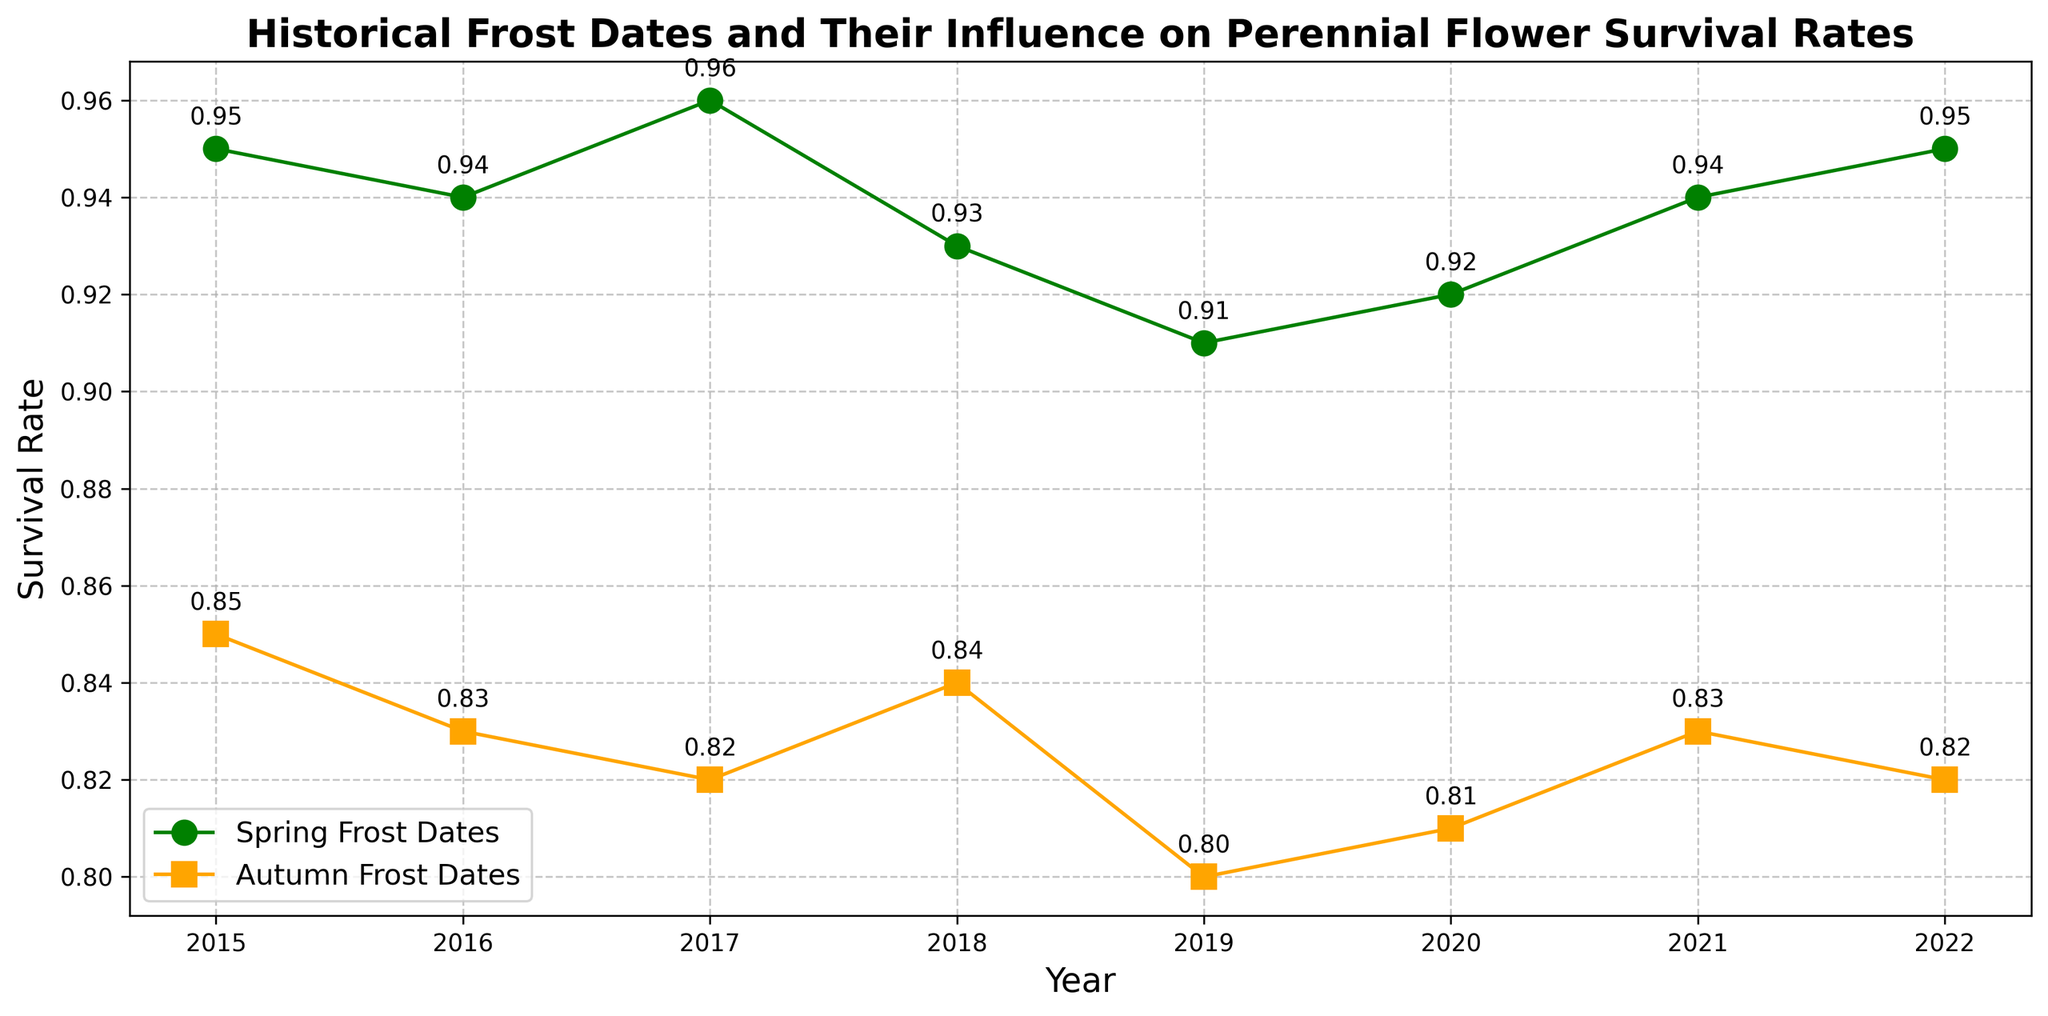What years saw the highest survival rate for spring frost dates? To find the highest survival rate for spring frost dates, we look at the green markers in the figure and identify the highest values along the y-axis. Both 2017 and 2022 show a survival rate of 0.96.
Answer: 2017 and 2022 How does the average survival rate for autumn frost dates compare to spring frost dates from 2015 to 2022? First, find the average survival rate for both autumn and spring frost dates separately. For autumn, add survival rates from all autumn markers and divide by the number of years: (0.85 + 0.83 + 0.82 + 0.84 + 0.80 + 0.81 + 0.83 + 0.82)/8. For spring: (0.95 + 0.94 + 0.96 + 0.93 + 0.91 + 0.92 + 0.94 + 0.95)/8. Compare the two averages.
Answer: Autumn: 0.825, Spring: 0.9375 Which year had the largest difference in survival rates between spring and autumn frost dates? Calculate the difference for each year by subtracting the autumn survival rate from the spring survival rate. The largest difference is seen in 2017, where the difference is 0.96 - 0.82 = 0.14.
Answer: 2017 Are there any years where the survival rate for spring frost dates was the same as the following year's autumn frost dates? Compare the survival rates of the spring frost dates of each year to the autumn frost dates of the following year. None of the values are the same.
Answer: No What general trend can you observe in the survival rates for autumn frost dates over time? Look at the orange markers representing autumn frost dates and observe their positioning along the y-axis over time. The rates appear to slightly decrease from 2015 to 2022.
Answer: Decrease How did the survival rate for autumn frost dates change from 2016 to 2017? Compare the survival rate values for autumn in 2016 (0.83) and 2017 (0.82). The rate decreased by 0.01 from 2016 to 2017.
Answer: Decrease by 0.01 What is the survival rate for spring frost dates in 2018, and how does it compare to the survival rate for autumn frost dates in the same year? The survival rate for spring frost dates in 2018 is 0.93, and for autumn frost dates, it's 0.84. Comparing the two rates, spring has a higher survival rate than autumn by 0.09.
Answer: 0.93, higher by 0.09 